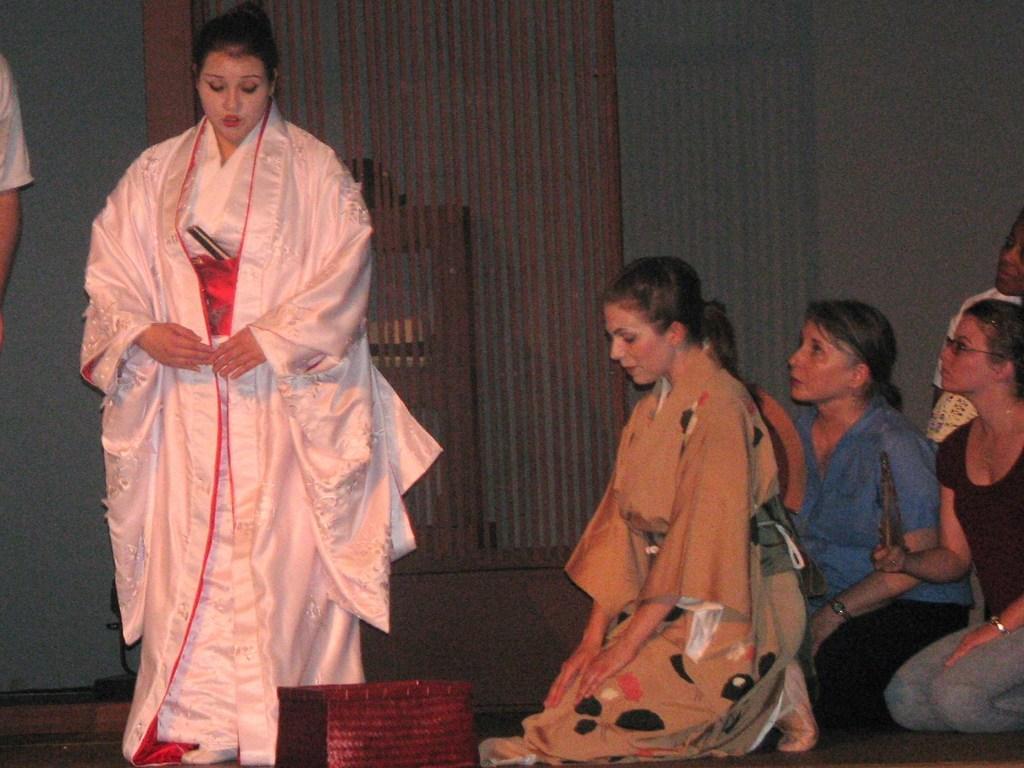How would you summarize this image in a sentence or two? In this image we can see a few women on the floor and they are on the right side. Here we can see a woman walking on the floor and she is on the left side. Here we can see the hand of a person, through his face is not visible. 